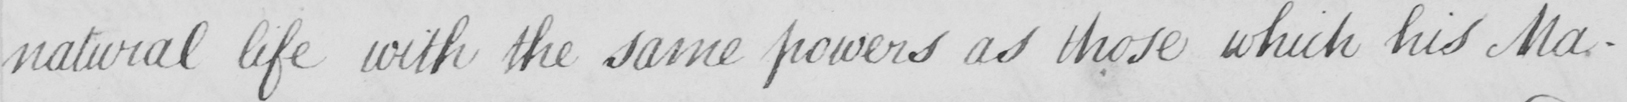What is written in this line of handwriting? natural life with the same powers as those which his Ma- 